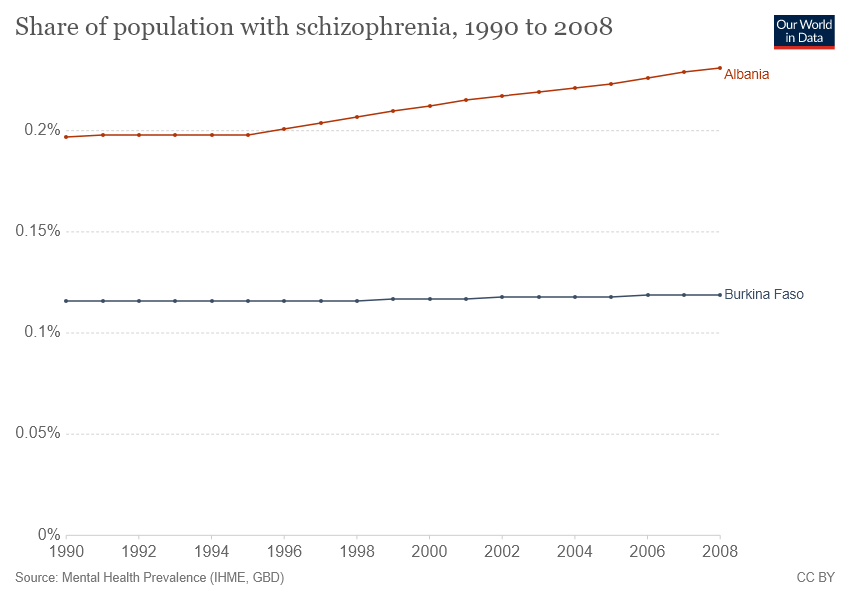Point out several critical features in this image. The grey bar represents Burkina Faso. In 1999, I was able to observe a significant change in the percentage of Burkina Faso bars. 